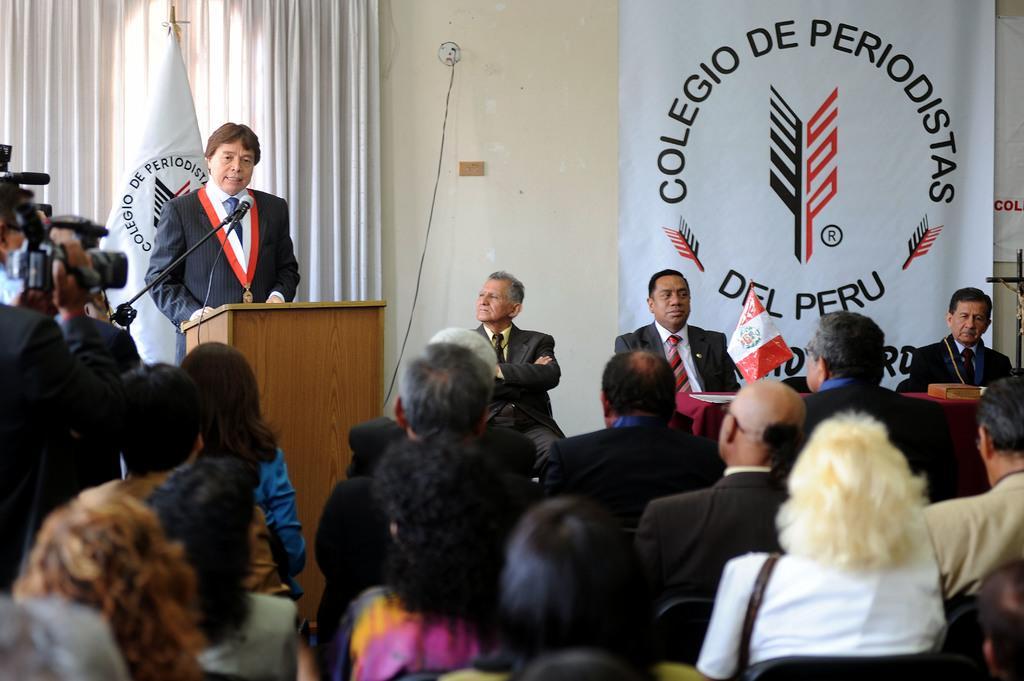Could you give a brief overview of what you see in this image? In this image at the left side a person is standing in front of the dais and he was talking on mike. At the back side there is a flag and at the background there are curtains. At the center there is a banner attached to the wall and in front of the banner people were sitting on the chairs. In front of them there is table and on top of the table there is a book and a flag. At front there are few people sitting on the chairs and few people standing by holding the camera. 